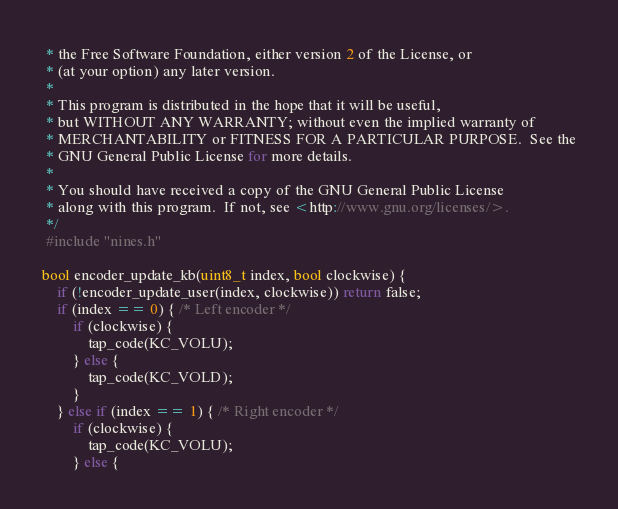Convert code to text. <code><loc_0><loc_0><loc_500><loc_500><_C_> * the Free Software Foundation, either version 2 of the License, or
 * (at your option) any later version.
 *
 * This program is distributed in the hope that it will be useful,
 * but WITHOUT ANY WARRANTY; without even the implied warranty of
 * MERCHANTABILITY or FITNESS FOR A PARTICULAR PURPOSE.  See the
 * GNU General Public License for more details.
 *
 * You should have received a copy of the GNU General Public License
 * along with this program.  If not, see <http://www.gnu.org/licenses/>.
 */
 #include "nines.h"

bool encoder_update_kb(uint8_t index, bool clockwise) {
    if (!encoder_update_user(index, clockwise)) return false;
    if (index == 0) { /* Left encoder */
        if (clockwise) {
            tap_code(KC_VOLU);
        } else {
            tap_code(KC_VOLD);
        }
    } else if (index == 1) { /* Right encoder */
        if (clockwise) {
            tap_code(KC_VOLU);
        } else {</code> 